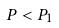Convert formula to latex. <formula><loc_0><loc_0><loc_500><loc_500>P < P _ { 1 }</formula> 